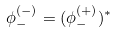<formula> <loc_0><loc_0><loc_500><loc_500>\phi _ { - } ^ { ( - ) } = ( \phi _ { - } ^ { ( + ) } ) ^ { * }</formula> 